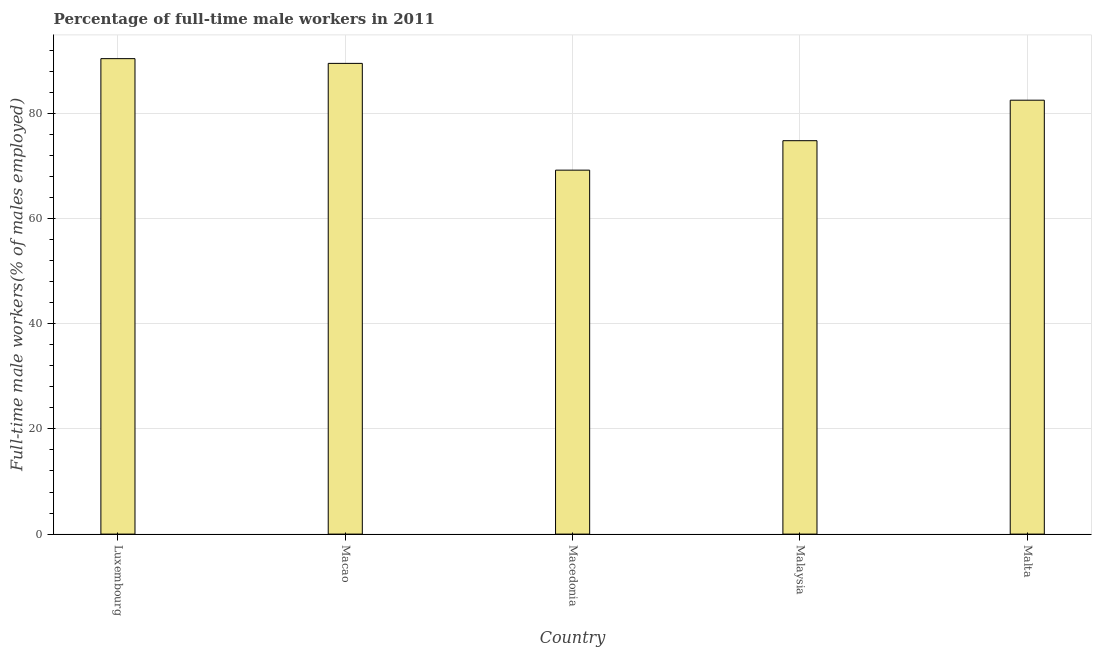Does the graph contain any zero values?
Make the answer very short. No. What is the title of the graph?
Provide a succinct answer. Percentage of full-time male workers in 2011. What is the label or title of the Y-axis?
Provide a succinct answer. Full-time male workers(% of males employed). What is the percentage of full-time male workers in Macao?
Offer a very short reply. 89.5. Across all countries, what is the maximum percentage of full-time male workers?
Ensure brevity in your answer.  90.4. Across all countries, what is the minimum percentage of full-time male workers?
Offer a terse response. 69.2. In which country was the percentage of full-time male workers maximum?
Your answer should be very brief. Luxembourg. In which country was the percentage of full-time male workers minimum?
Provide a short and direct response. Macedonia. What is the sum of the percentage of full-time male workers?
Offer a very short reply. 406.4. What is the difference between the percentage of full-time male workers in Macao and Macedonia?
Provide a short and direct response. 20.3. What is the average percentage of full-time male workers per country?
Make the answer very short. 81.28. What is the median percentage of full-time male workers?
Your answer should be very brief. 82.5. In how many countries, is the percentage of full-time male workers greater than 48 %?
Give a very brief answer. 5. What is the ratio of the percentage of full-time male workers in Luxembourg to that in Malaysia?
Make the answer very short. 1.21. What is the difference between the highest and the second highest percentage of full-time male workers?
Offer a very short reply. 0.9. What is the difference between the highest and the lowest percentage of full-time male workers?
Provide a short and direct response. 21.2. In how many countries, is the percentage of full-time male workers greater than the average percentage of full-time male workers taken over all countries?
Provide a short and direct response. 3. How many countries are there in the graph?
Ensure brevity in your answer.  5. What is the Full-time male workers(% of males employed) in Luxembourg?
Provide a succinct answer. 90.4. What is the Full-time male workers(% of males employed) in Macao?
Offer a very short reply. 89.5. What is the Full-time male workers(% of males employed) in Macedonia?
Keep it short and to the point. 69.2. What is the Full-time male workers(% of males employed) of Malaysia?
Offer a terse response. 74.8. What is the Full-time male workers(% of males employed) of Malta?
Your response must be concise. 82.5. What is the difference between the Full-time male workers(% of males employed) in Luxembourg and Macao?
Provide a short and direct response. 0.9. What is the difference between the Full-time male workers(% of males employed) in Luxembourg and Macedonia?
Provide a short and direct response. 21.2. What is the difference between the Full-time male workers(% of males employed) in Luxembourg and Malaysia?
Your answer should be very brief. 15.6. What is the difference between the Full-time male workers(% of males employed) in Macao and Macedonia?
Provide a short and direct response. 20.3. What is the difference between the Full-time male workers(% of males employed) in Macedonia and Malaysia?
Provide a succinct answer. -5.6. What is the difference between the Full-time male workers(% of males employed) in Macedonia and Malta?
Provide a succinct answer. -13.3. What is the ratio of the Full-time male workers(% of males employed) in Luxembourg to that in Macedonia?
Your response must be concise. 1.31. What is the ratio of the Full-time male workers(% of males employed) in Luxembourg to that in Malaysia?
Your response must be concise. 1.21. What is the ratio of the Full-time male workers(% of males employed) in Luxembourg to that in Malta?
Your response must be concise. 1.1. What is the ratio of the Full-time male workers(% of males employed) in Macao to that in Macedonia?
Your answer should be very brief. 1.29. What is the ratio of the Full-time male workers(% of males employed) in Macao to that in Malaysia?
Provide a succinct answer. 1.2. What is the ratio of the Full-time male workers(% of males employed) in Macao to that in Malta?
Give a very brief answer. 1.08. What is the ratio of the Full-time male workers(% of males employed) in Macedonia to that in Malaysia?
Provide a succinct answer. 0.93. What is the ratio of the Full-time male workers(% of males employed) in Macedonia to that in Malta?
Your answer should be compact. 0.84. What is the ratio of the Full-time male workers(% of males employed) in Malaysia to that in Malta?
Ensure brevity in your answer.  0.91. 